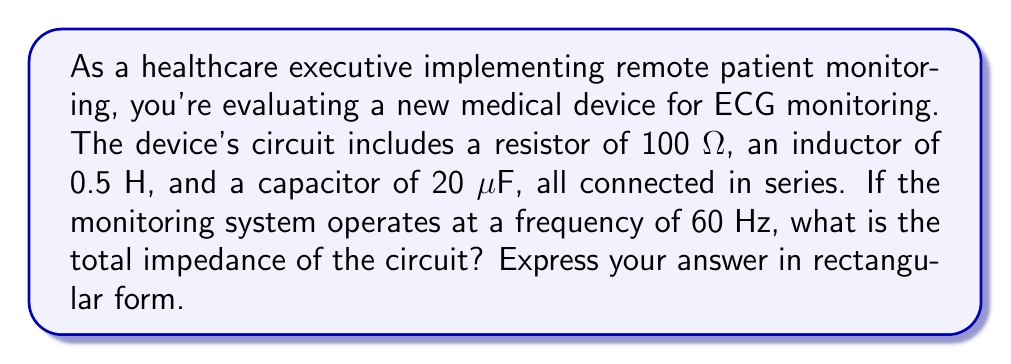Give your solution to this math problem. To solve this problem, we need to follow these steps:

1) First, let's recall the formulas for impedance of each component:
   - Resistor: $Z_R = R$
   - Inductor: $Z_L = j\omega L$
   - Capacitor: $Z_C = \frac{1}{j\omega C}$

   Where $\omega = 2\pi f$ is the angular frequency, $f$ is the frequency in Hz, $j$ is the imaginary unit.

2) Calculate $\omega$:
   $\omega = 2\pi f = 2\pi(60) = 120\pi$ rad/s

3) Calculate the impedances:
   - $Z_R = 100$ Ω
   - $Z_L = j\omega L = j(120\pi)(0.5) = j188.5$ Ω
   - $Z_C = \frac{1}{j\omega C} = \frac{1}{j(120\pi)(20 \times 10^{-6})} = -j132.6$ Ω

4) In a series circuit, we add the impedances:
   $Z_{total} = Z_R + Z_L + Z_C$
   $Z_{total} = 100 + j188.5 - j132.6$
   $Z_{total} = 100 + j55.9$

5) This is already in rectangular form, so no further conversion is needed.
Answer: $Z_{total} = 100 + j55.9$ Ω 